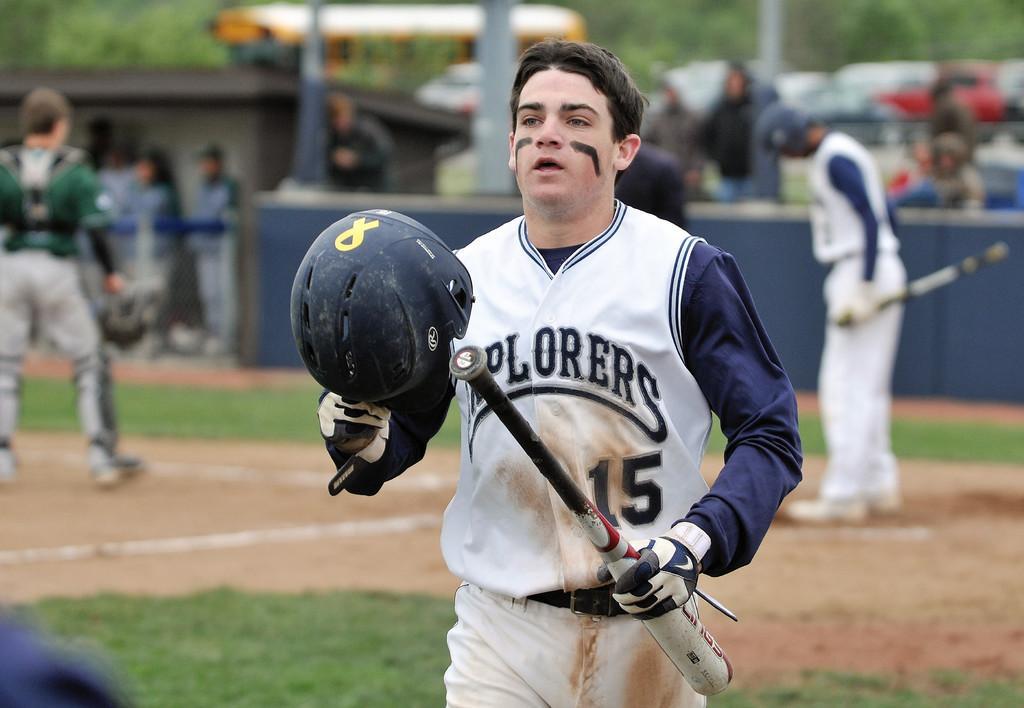Could you give a brief overview of what you see in this image? In this picture I can see there is a man walking here and he is wearing a white jersey, a white pant and he is holding a baseball in his left and hand and holding a helmet in his right hand, in the backdrop on to left there is a man standing, he is wearing a white jersey, a pant and wearing a helmet and holding a baseball bat. There is another person standing on to right and the backdrop is blurred. 